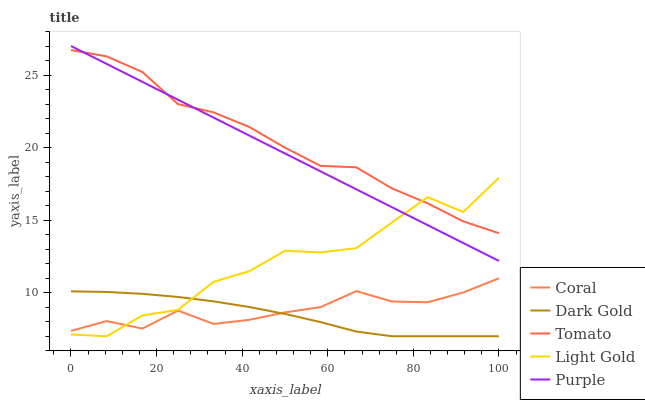Does Dark Gold have the minimum area under the curve?
Answer yes or no. Yes. Does Tomato have the maximum area under the curve?
Answer yes or no. Yes. Does Purple have the minimum area under the curve?
Answer yes or no. No. Does Purple have the maximum area under the curve?
Answer yes or no. No. Is Purple the smoothest?
Answer yes or no. Yes. Is Light Gold the roughest?
Answer yes or no. Yes. Is Coral the smoothest?
Answer yes or no. No. Is Coral the roughest?
Answer yes or no. No. Does Light Gold have the lowest value?
Answer yes or no. Yes. Does Purple have the lowest value?
Answer yes or no. No. Does Purple have the highest value?
Answer yes or no. Yes. Does Coral have the highest value?
Answer yes or no. No. Is Coral less than Tomato?
Answer yes or no. Yes. Is Purple greater than Dark Gold?
Answer yes or no. Yes. Does Coral intersect Light Gold?
Answer yes or no. Yes. Is Coral less than Light Gold?
Answer yes or no. No. Is Coral greater than Light Gold?
Answer yes or no. No. Does Coral intersect Tomato?
Answer yes or no. No. 